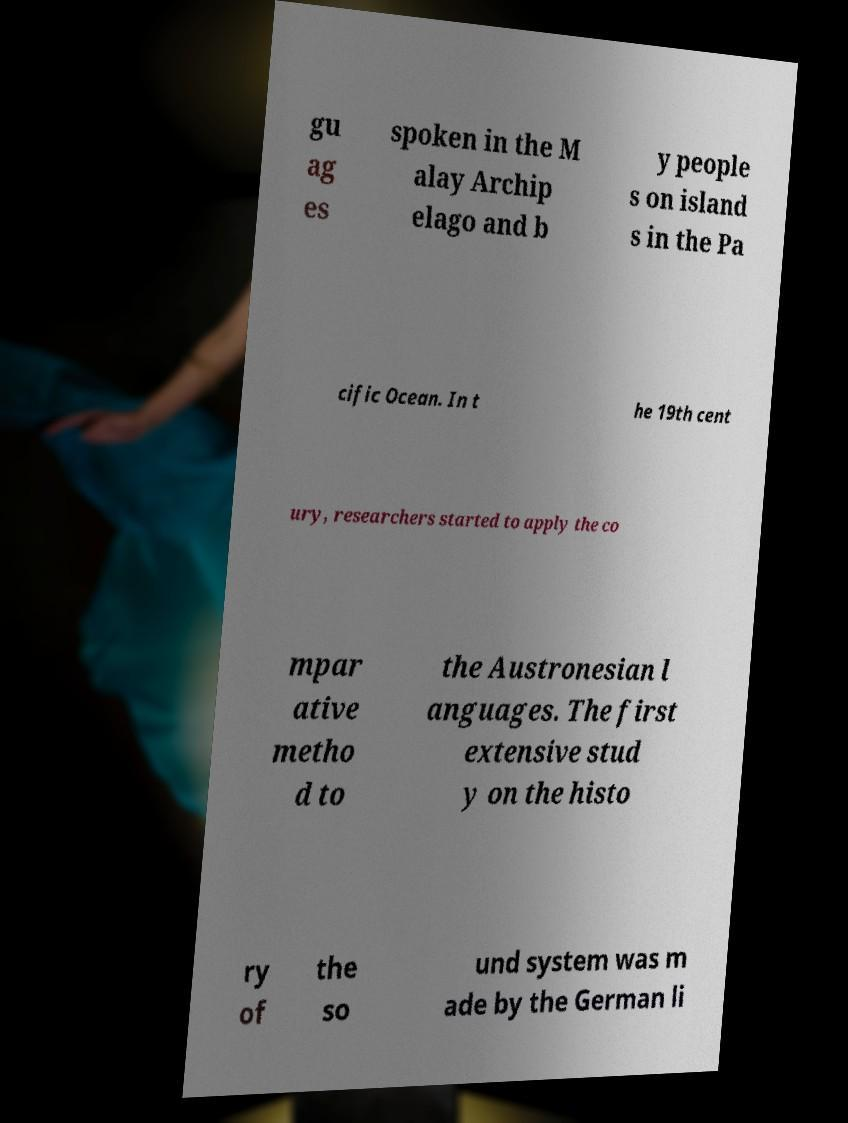I need the written content from this picture converted into text. Can you do that? gu ag es spoken in the M alay Archip elago and b y people s on island s in the Pa cific Ocean. In t he 19th cent ury, researchers started to apply the co mpar ative metho d to the Austronesian l anguages. The first extensive stud y on the histo ry of the so und system was m ade by the German li 